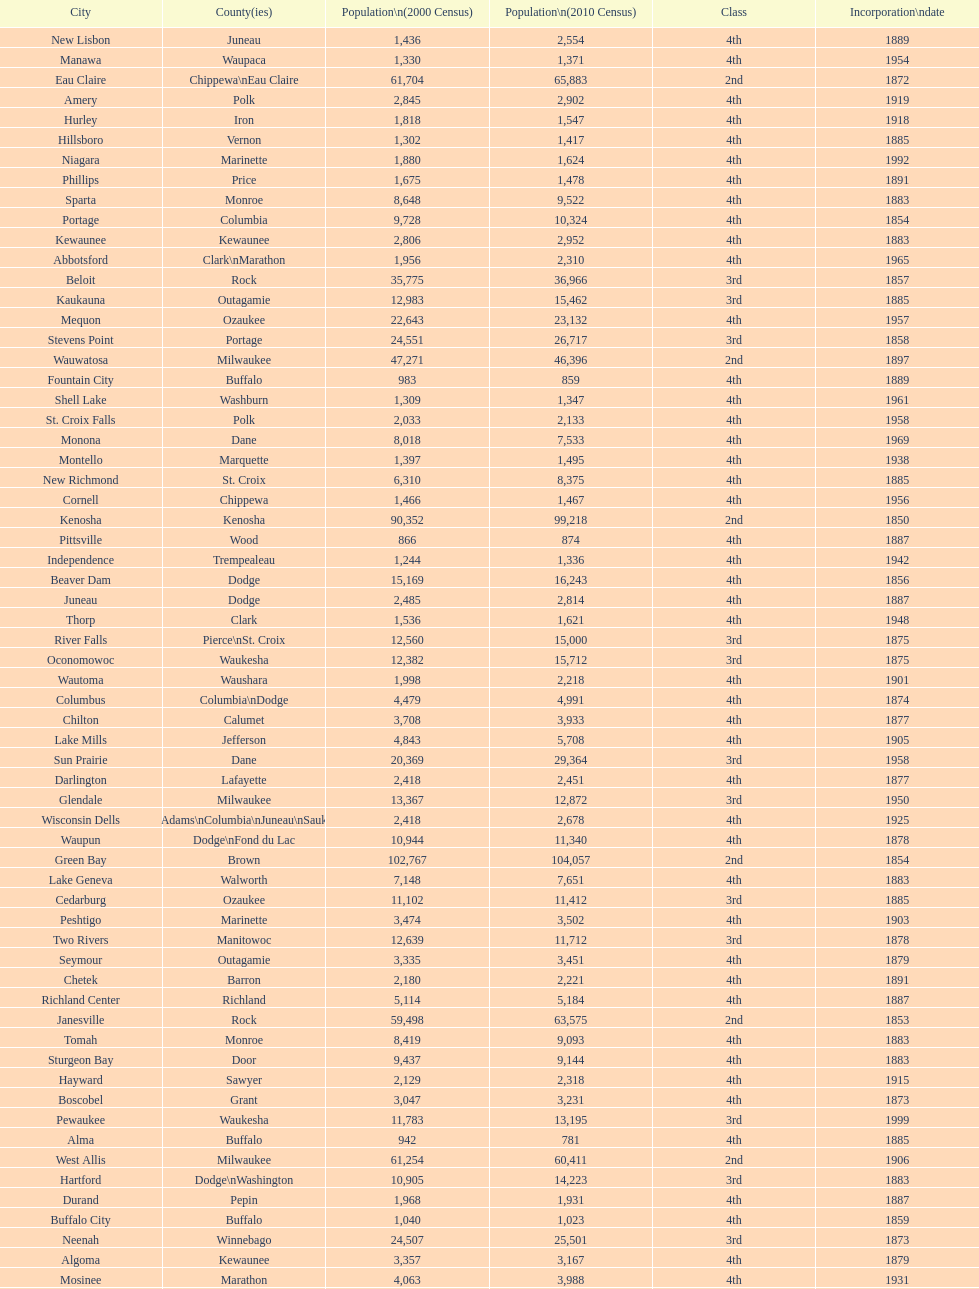What was the first city to be incorporated into wisconsin? Chippewa Falls. 